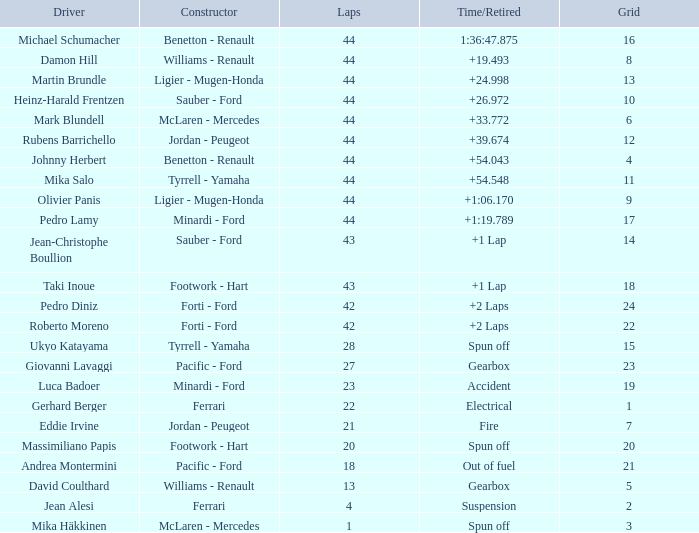What is the peak lap sum for cards with a grid greater than 21, and a time/retired of +2 laps? 42.0. 